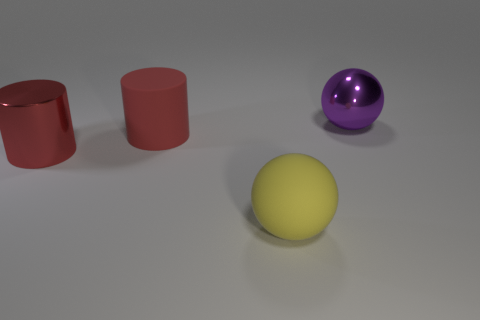Are there fewer large red matte cylinders than large red cubes?
Make the answer very short. No. There is a matte object that is the same shape as the large red metallic thing; what is its color?
Your answer should be compact. Red. Is there anything else that has the same shape as the purple thing?
Offer a very short reply. Yes. Is the number of big red shiny cylinders greater than the number of small cyan cylinders?
Offer a very short reply. Yes. How many other things are there of the same material as the yellow thing?
Keep it short and to the point. 1. The metallic thing to the left of the big ball on the right side of the big ball in front of the big red matte cylinder is what shape?
Provide a succinct answer. Cylinder. Is the number of metal things on the left side of the big red rubber cylinder less than the number of red objects behind the purple metal ball?
Offer a terse response. No. Is there a matte object of the same color as the metal cylinder?
Ensure brevity in your answer.  Yes. Is the material of the purple object the same as the sphere that is on the left side of the large purple thing?
Offer a very short reply. No. Is there a large yellow thing that is on the right side of the purple metallic object that is on the right side of the large matte ball?
Offer a very short reply. No. 